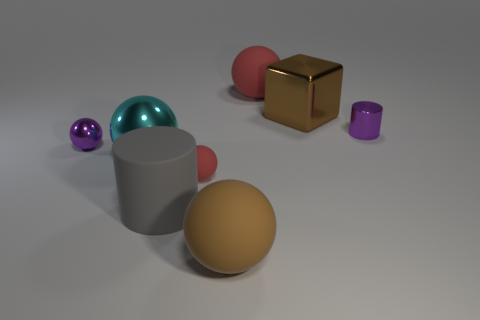There is a tiny purple object that is the same shape as the gray thing; what is it made of?
Offer a terse response. Metal. What is the color of the tiny rubber ball?
Provide a short and direct response. Red. Do the small cylinder and the small metallic sphere have the same color?
Your answer should be compact. Yes. There is a brown block that is behind the large cyan sphere; how many balls are in front of it?
Your response must be concise. 4. There is a shiny thing that is both to the right of the large metallic ball and in front of the large shiny block; what is its size?
Give a very brief answer. Small. What is the small object behind the tiny purple metallic ball made of?
Offer a terse response. Metal. Is there a large rubber object that has the same shape as the small red object?
Your answer should be compact. Yes. What number of other tiny things have the same shape as the brown matte object?
Offer a very short reply. 2. Do the cylinder that is behind the large cylinder and the brown thing that is behind the small rubber thing have the same size?
Your answer should be very brief. No. What shape is the tiny purple shiny object right of the rubber ball behind the large brown metal block?
Offer a very short reply. Cylinder. 